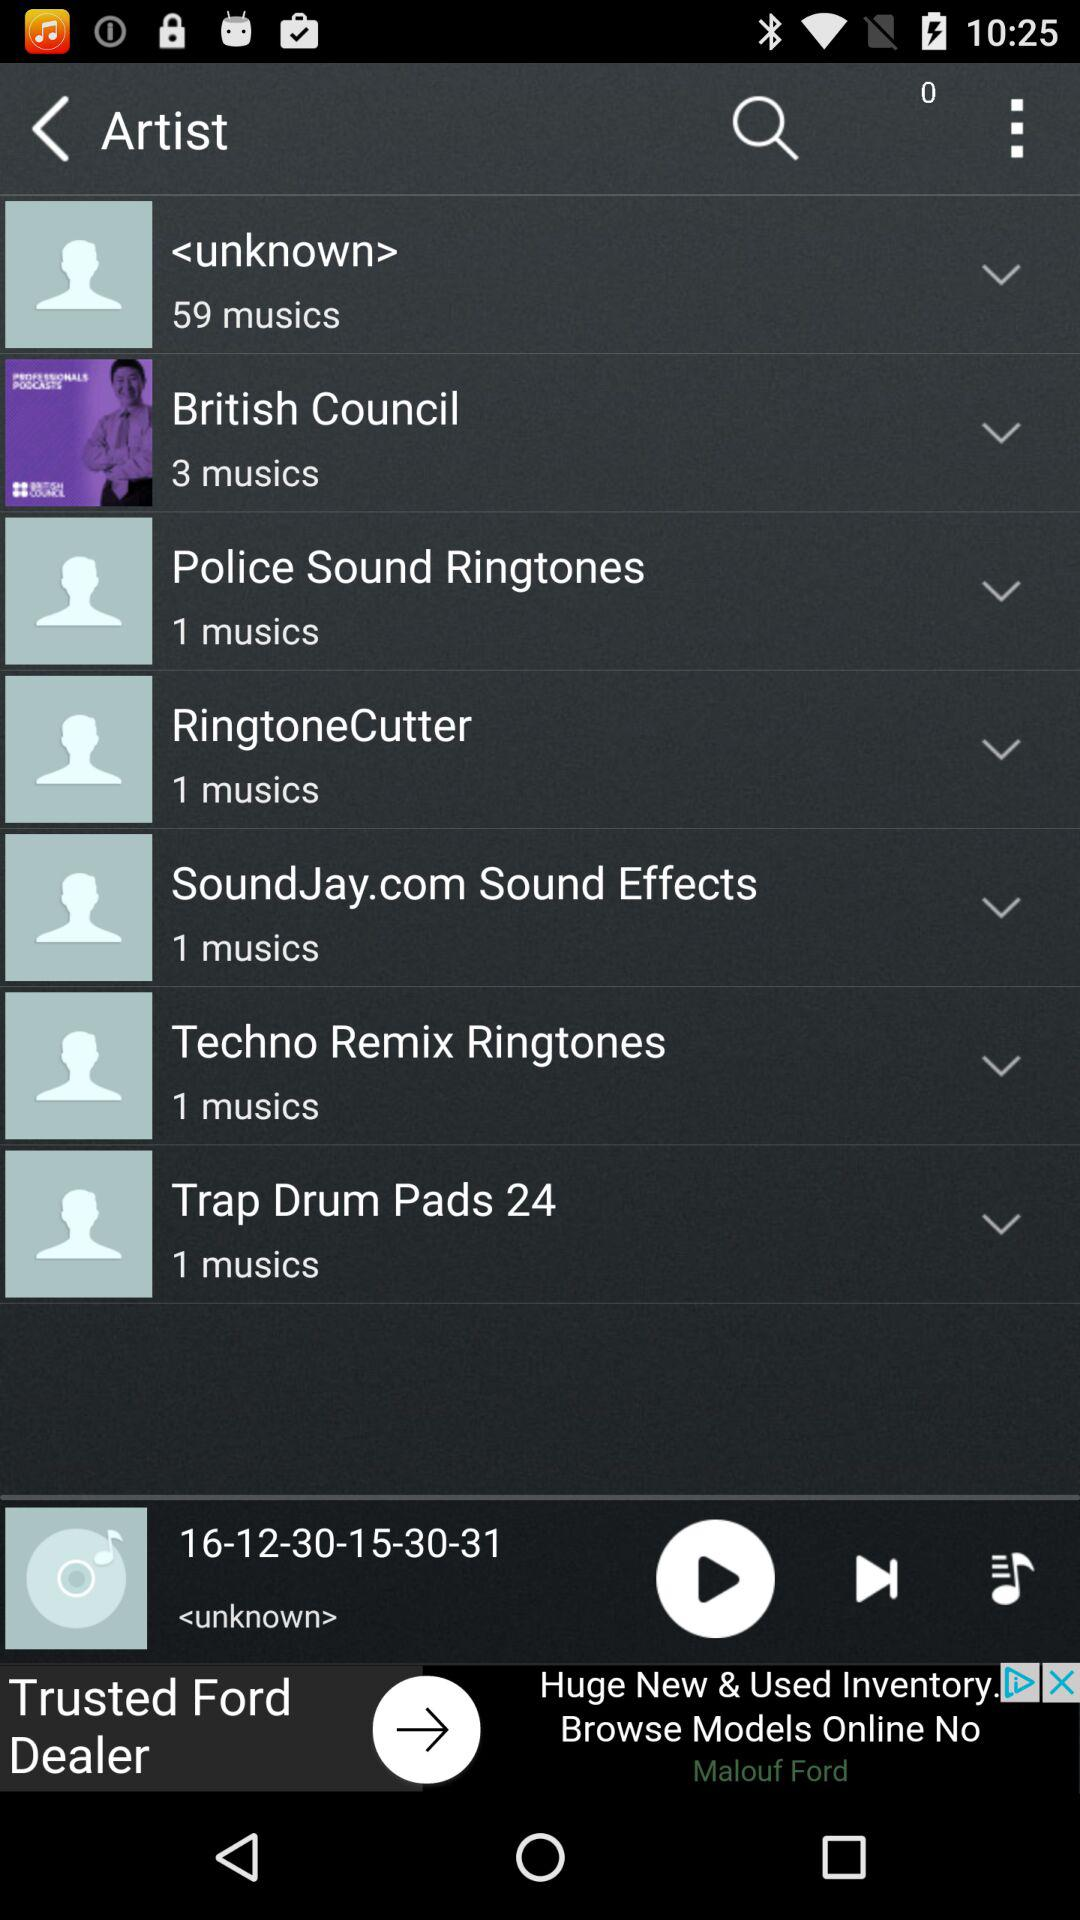How many songs are available in "British Council"? The number of songs available in "British Council" is 3. 